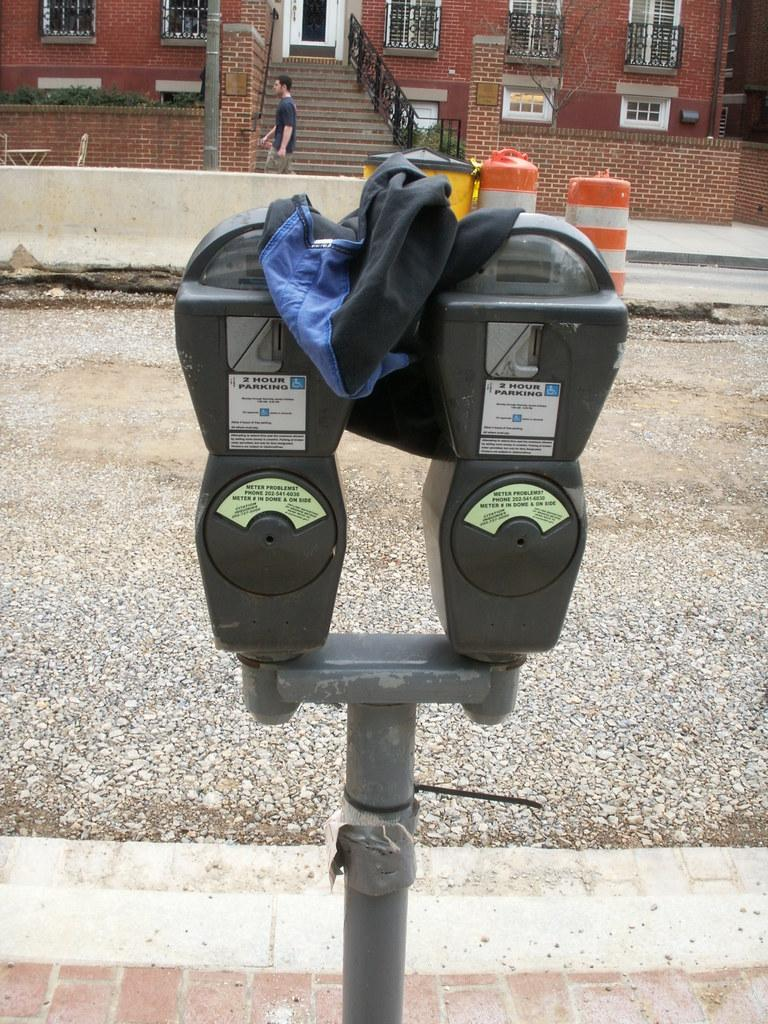<image>
Create a compact narrative representing the image presented. Two parking meters with 2 Hour Parking signs are on a post. 